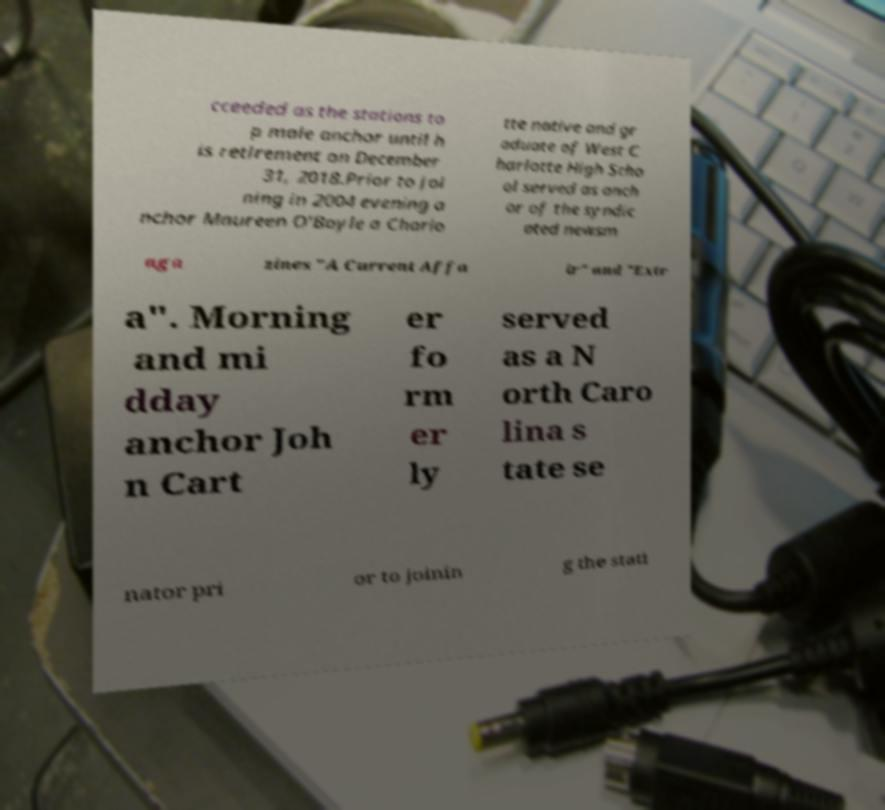What messages or text are displayed in this image? I need them in a readable, typed format. cceeded as the stations to p male anchor until h is retirement on December 31, 2018.Prior to joi ning in 2004 evening a nchor Maureen O'Boyle a Charlo tte native and gr aduate of West C harlotte High Scho ol served as anch or of the syndic ated newsm aga zines "A Current Affa ir" and "Extr a". Morning and mi dday anchor Joh n Cart er fo rm er ly served as a N orth Caro lina s tate se nator pri or to joinin g the stati 